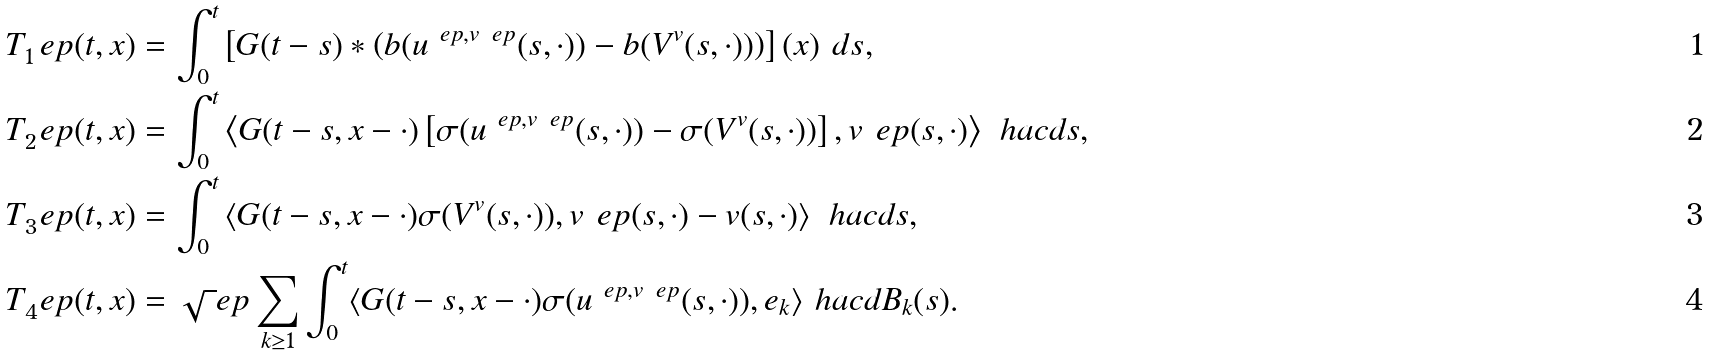Convert formula to latex. <formula><loc_0><loc_0><loc_500><loc_500>T _ { 1 } ^ { \ } e p ( t , x ) & = \int _ { 0 } ^ { t } \left [ G ( t - s ) * \left ( b ( u ^ { \ e p , v ^ { \ } e p } ( s , \cdot ) ) - b ( V ^ { v } ( s , \cdot ) ) \right ) \right ] ( x ) \ d s , \\ T _ { 2 } ^ { \ } e p ( t , x ) & = \int _ { 0 } ^ { t } \left \langle G ( t - s , x - \cdot ) \left [ \sigma ( u ^ { \ e p , v ^ { \ } e p } ( s , \cdot ) ) - \sigma ( V ^ { v } ( s , \cdot ) ) \right ] , v ^ { \ } e p ( s , \cdot ) \right \rangle _ { \ } h a c d s , \\ T _ { 3 } ^ { \ } e p ( t , x ) & = \int _ { 0 } ^ { t } \left \langle G ( t - s , x - \cdot ) \sigma ( V ^ { v } ( s , \cdot ) ) , v ^ { \ } e p ( s , \cdot ) - v ( s , \cdot ) \right \rangle _ { \ } h a c d s , \\ T _ { 4 } ^ { \ } e p ( t , x ) & = \sqrt { \ } e p \sum _ { k \geq 1 } \int _ { 0 } ^ { t } \langle G ( t - s , x - \cdot ) \sigma ( u ^ { \ e p , v ^ { \ } e p } ( s , \cdot ) ) , e _ { k } \rangle _ { \ } h a c d B _ { k } ( s ) .</formula> 